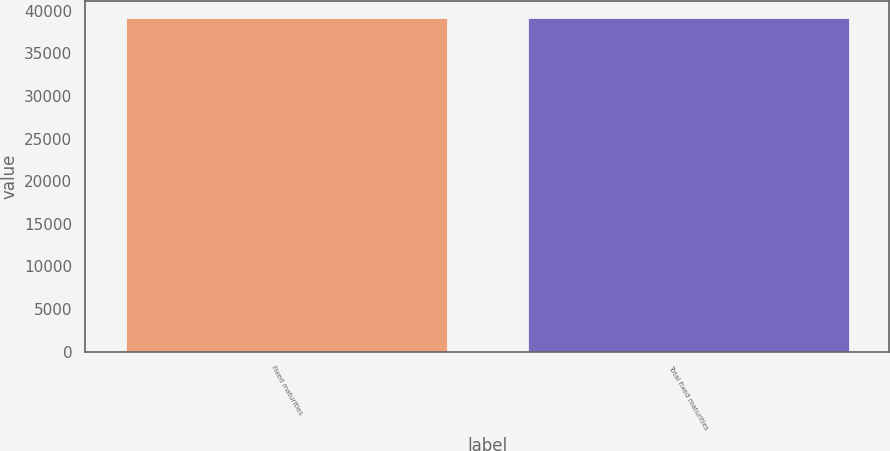Convert chart to OTSL. <chart><loc_0><loc_0><loc_500><loc_500><bar_chart><fcel>Fixed maturities<fcel>Total fixed maturities<nl><fcel>39101<fcel>39136<nl></chart> 